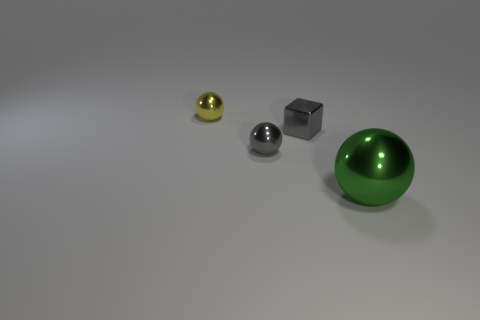Is there anything else that is the same size as the green metallic sphere?
Offer a terse response. No. How many metal balls have the same color as the tiny metallic block?
Ensure brevity in your answer.  1. What size is the green sphere that is made of the same material as the yellow sphere?
Make the answer very short. Large. What is the size of the other gray metallic thing that is the same shape as the big thing?
Give a very brief answer. Small. How big is the shiny thing that is both right of the gray metal ball and in front of the tiny gray metallic block?
Give a very brief answer. Large. Is the color of the small cube the same as the small ball that is on the right side of the yellow thing?
Keep it short and to the point. Yes. There is a metal sphere that is on the right side of the gray object that is in front of the gray shiny block; what size is it?
Provide a succinct answer. Large. Are there the same number of big balls behind the big green ball and large metal objects in front of the small gray metal cube?
Your response must be concise. No. There is a sphere that is in front of the small yellow shiny object and behind the green thing; what is its material?
Your response must be concise. Metal. There is a yellow object; is it the same size as the gray object right of the tiny gray metallic sphere?
Keep it short and to the point. Yes. 